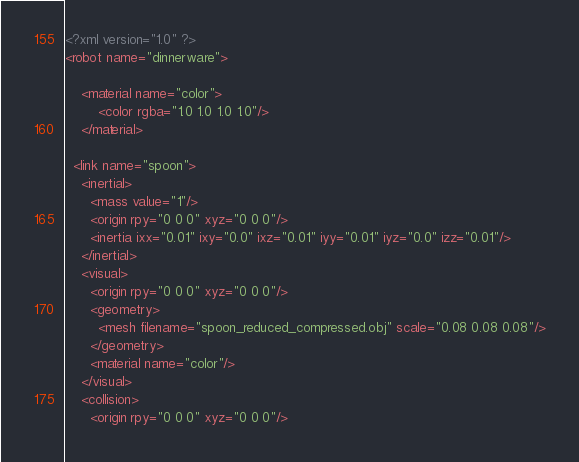<code> <loc_0><loc_0><loc_500><loc_500><_XML_><?xml version="1.0" ?>
<robot name="dinnerware">

    <material name="color">
        <color rgba="1.0 1.0 1.0 1.0"/>
    </material>

  <link name="spoon">
    <inertial>
      <mass value="1"/>
      <origin rpy="0 0 0" xyz="0 0 0"/>
      <inertia ixx="0.01" ixy="0.0" ixz="0.01" iyy="0.01" iyz="0.0" izz="0.01"/>
    </inertial>
    <visual>
      <origin rpy="0 0 0" xyz="0 0 0"/>
      <geometry>
        <mesh filename="spoon_reduced_compressed.obj" scale="0.08 0.08 0.08"/>
      </geometry>
      <material name="color"/>
    </visual>
    <collision>
      <origin rpy="0 0 0" xyz="0 0 0"/></code> 